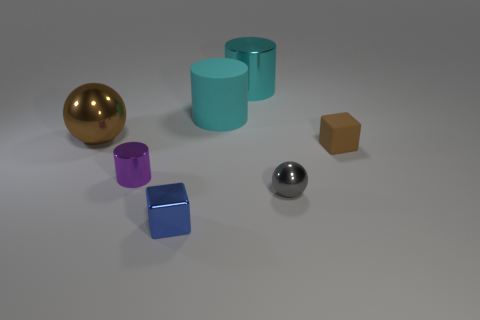Is the small gray metallic thing the same shape as the small brown matte object?
Give a very brief answer. No. How many small objects are either cyan rubber cylinders or cyan metal objects?
Give a very brief answer. 0. There is a gray ball; are there any brown metal objects in front of it?
Your answer should be very brief. No. Is the number of small gray spheres in front of the small gray thing the same as the number of big green metal cubes?
Your answer should be very brief. Yes. There is a blue metal thing that is the same shape as the small brown thing; what is its size?
Offer a very short reply. Small. There is a tiny brown matte object; is its shape the same as the small shiny object behind the gray object?
Make the answer very short. No. What is the size of the metallic sphere that is on the left side of the ball to the right of the shiny block?
Provide a short and direct response. Large. Are there the same number of brown rubber blocks in front of the purple metallic cylinder and brown metallic things on the right side of the large sphere?
Provide a succinct answer. Yes. The other metal object that is the same shape as the gray metallic object is what color?
Ensure brevity in your answer.  Brown. What number of small metal spheres have the same color as the tiny rubber block?
Provide a succinct answer. 0. 